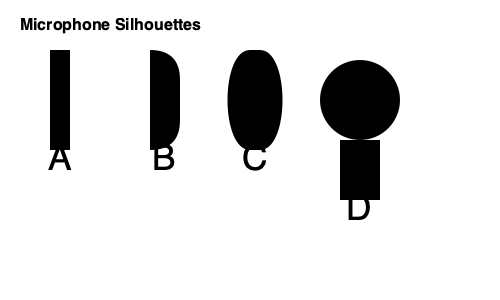As a country musician who performs at karaoke nights, you're familiar with various microphone types. Which silhouette represents the dynamic microphone most commonly used for live vocal performances in small venues? Let's analyze each microphone silhouette:

1. Silhouette A: This represents a pencil or shotgun microphone, typically used for recording audio in film or television production. It's not commonly used for live vocal performances.

2. Silhouette B: This shows a large diaphragm condenser microphone, often used in studio recording settings. While excellent for capturing detailed vocal nuances, it's less suitable for live performances due to its sensitivity and fragility.

3. Silhouette C: This silhouette depicts a dynamic microphone with a cardioid pickup pattern. It's the most common type used for live vocal performances, especially in small venues like restaurants with karaoke nights. Its rugged design, good feedback rejection, and ability to handle high sound pressure levels make it ideal for live settings.

4. Silhouette D: This represents a ball-type microphone, often used in vintage-style recordings or as a specialty microphone. While it can be used for live performances, it's less common than the dynamic cardioid microphone.

For a country musician performing at karaoke nights in a restaurant, the most suitable and commonly encountered microphone would be the dynamic microphone represented by Silhouette C.
Answer: C 